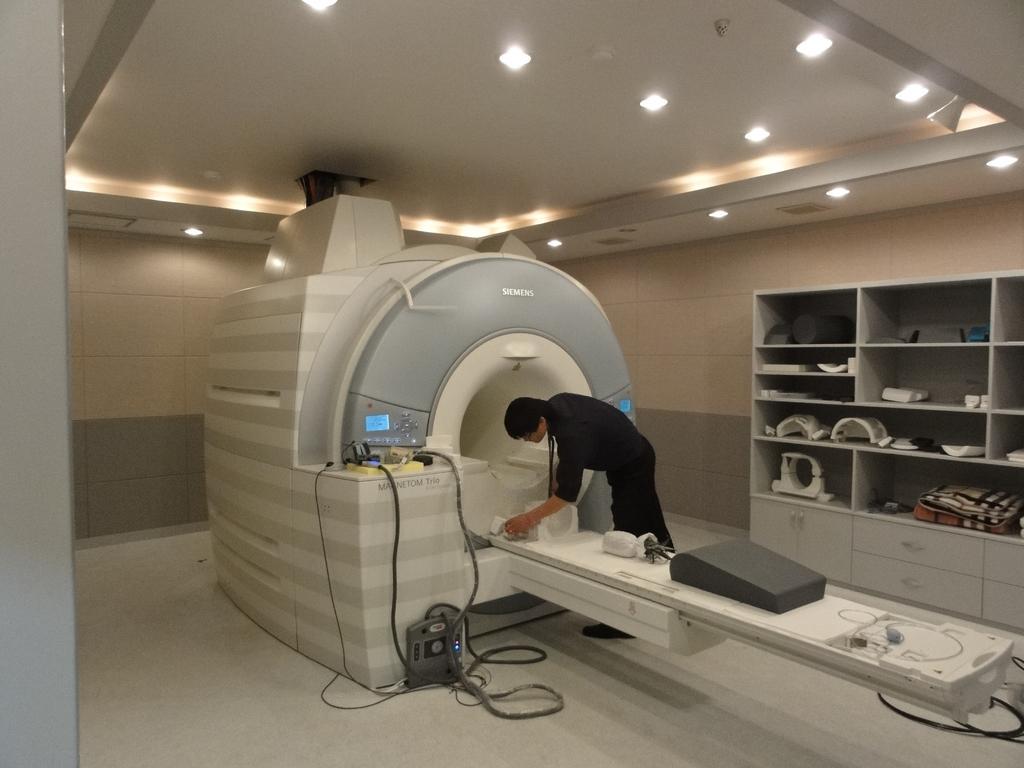Describe this image in one or two sentences. In this image we can see there is a hospital equipped with some objects and cables connected, there is a person standing, behind the person there are some objects arranged in the rack. At the top of the image there is a ceiling with lights. 